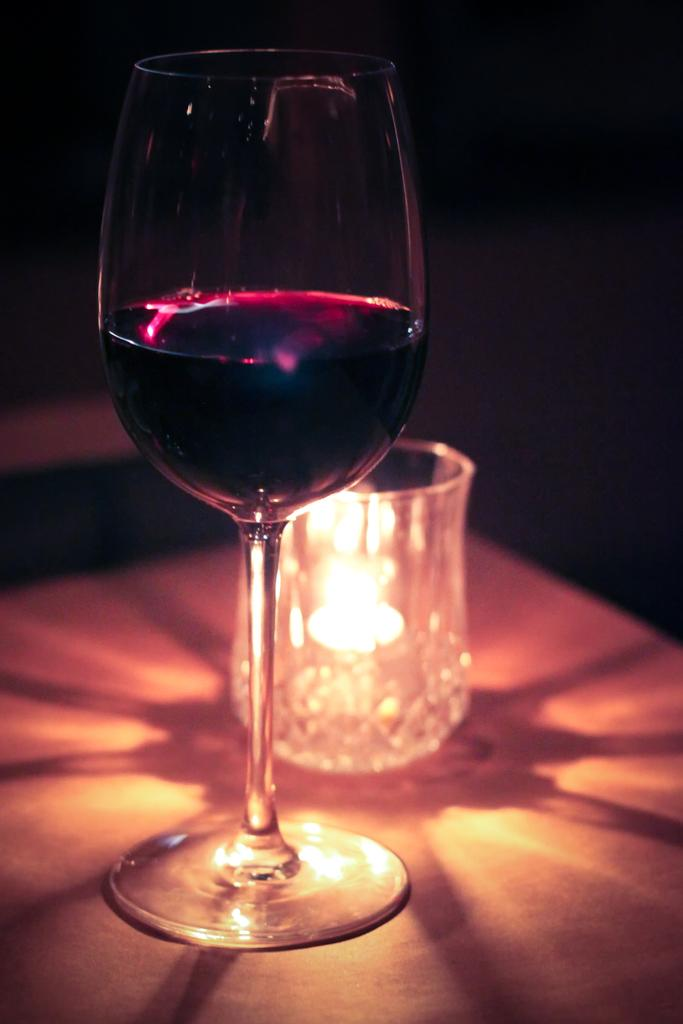What is inside the glass tumbler in the image? There is a beverage inside the glass tumbler in the image. What other object can be seen on the table in the image? There is a candle in a candle holder on the table in the image. Where are the glass tumbler and candle holder located in the image? Both the glass tumbler and candle holder are placed on a table in the image. What language is the impulse using to communicate with the example in the image? There is no impulse or example present in the image; it only features a glass tumbler with a beverage and a candle in a candle holder on a table. 